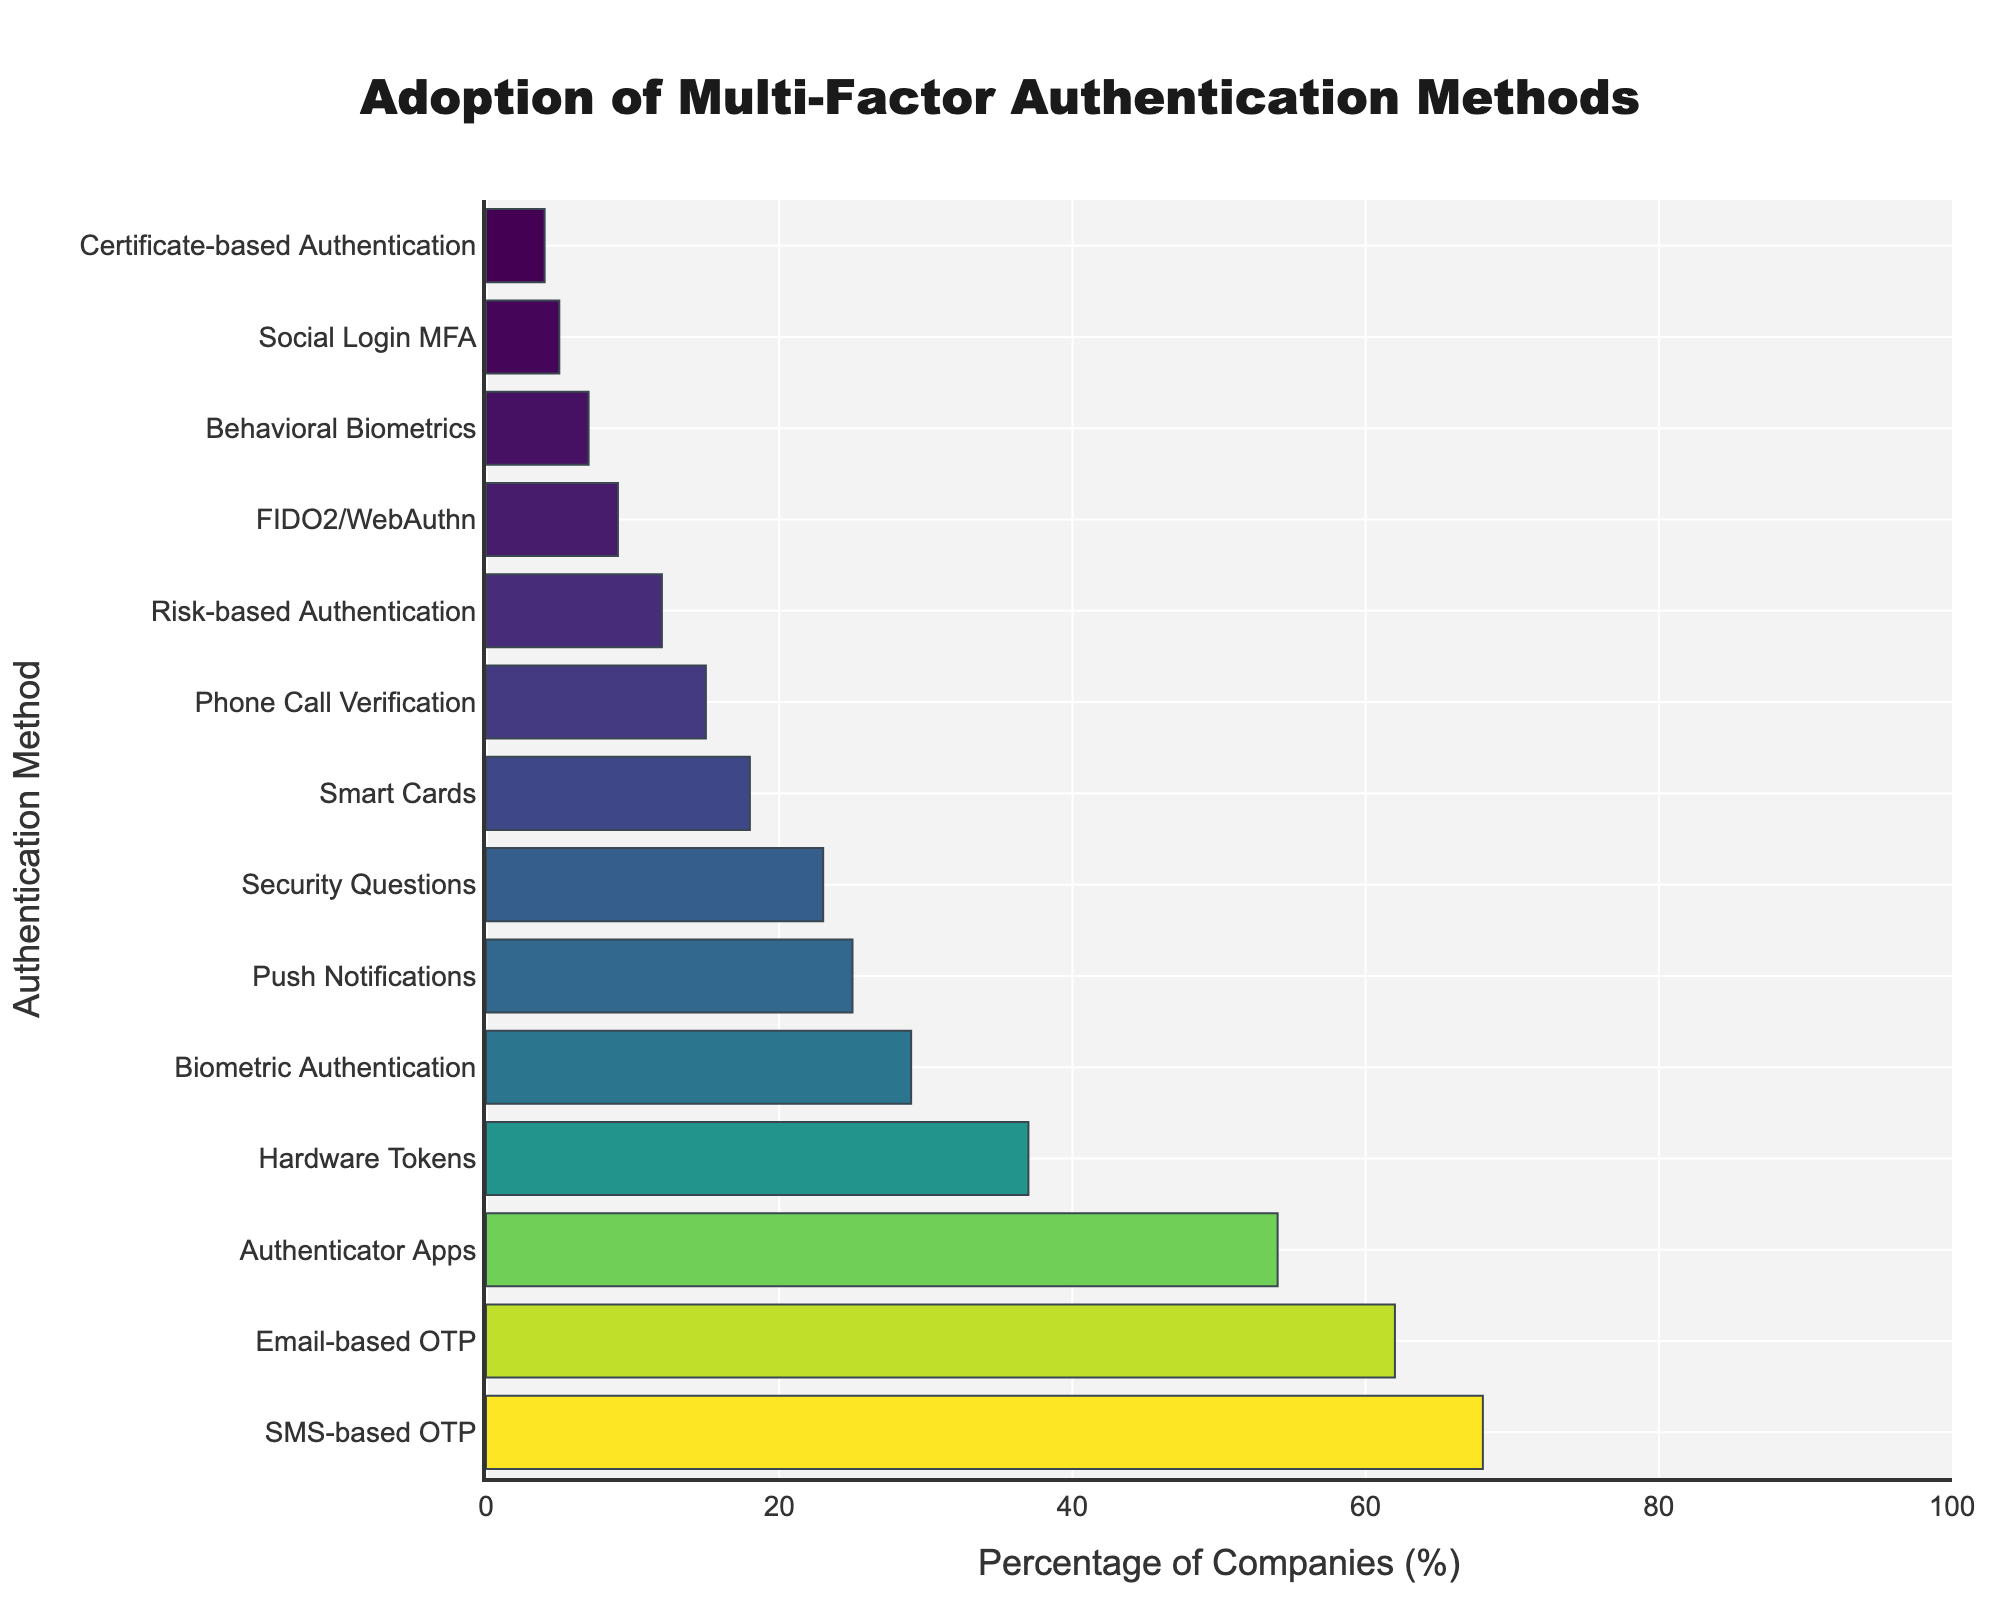What are the two most commonly adopted multi-factor authentication methods? The bar chart shows the percentage of companies adopting various multi-factor authentication methods. The two methods with the highest percentages are the most commonly adopted. In the chart, SMS-based OTP has the highest percentage (68%) followed by Email-based OTP (62%).
Answer: SMS-based OTP and Email-based OTP Which method has the lowest adoption rate? The bar chart displays the percentages in a descending order from top to bottom. The method at the bottom would have the lowest adoption rate. In this case, Certificate-based Authentication has the lowest adoption rate with 4%.
Answer: Certificate-based Authentication What is the average adoption percentage of Authenticator Apps, Hardware Tokens, and Biometric Authentication? Sum the percentages of these three methods and divide by the number of methods. Authenticator Apps (54%) + Hardware Tokens (37%) + Biometric Authentication (29%) = 120%. Divide by 3 to get the average. 120% / 3 = 40%.
Answer: 40% Which authentication method is more widely adopted: Push Notifications or Hardware Tokens? Compare the percentages of Push Notifications and Hardware Tokens based on their positions in the bar chart. Push Notifications has a percentage of 25%, whereas Hardware Tokens has a percentage of 37%.
Answer: Hardware Tokens How many methods have an adoption rate greater than 30%? Count the number of bars on the chart that are above the 30% line by checking the percentage values. There are four methods: SMS-based OTP (68%), Email-based OTP (62%), Authenticator Apps (54%), and Hardware Tokens (37%).
Answer: 4 Is the adoption rate of Social Login MFA and Security Questions equal? Compare the percentages of these two methods listed in the chart. Social Login MFA has 5%, while Security Questions has 23%.
Answer: No What is the total adoption percentage of the top three methods combined? Add the percentages of the top three methods. SMS-based OTP (68%) + Email-based OTP (62%) + Authenticator Apps (54%) = 184%.
Answer: 184% Which method has closer adoption rates: Risk-based Authentication and Behavioral Biometrics, or Phone Call Verification and Smart Cards? Compare the differences of the adoption rates between the pairs. Risk-based Authentication (12%) and Behavioral Biometrics (7%) have a difference of 5%, while Phone Call Verification (15%) and Smart Cards (18%) have a difference of 3%. The latter pair has closer adoption rates.
Answer: Phone Call Verification and Smart Cards Which authentication method falls in the middle in terms of adoption percentage? Find the median method by ordering all methods by their percentages and identifying the middle value. With 14 methods, the middle values are the 7th and 8th methods. Push Notifications (25%) and Security Questions (23%) fall in the middle.
Answer: Push Notifications or Security Questions How many methods have an adoption percentage less than or equal to 10%? Count the number of bars that are at or below the 10% line in the chart. The methods are FIDO2/WebAuthn (9%), Behavioral Biometrics (7%), Social Login MFA (5%), and Certificate-based Authentication (4%).
Answer: 4 